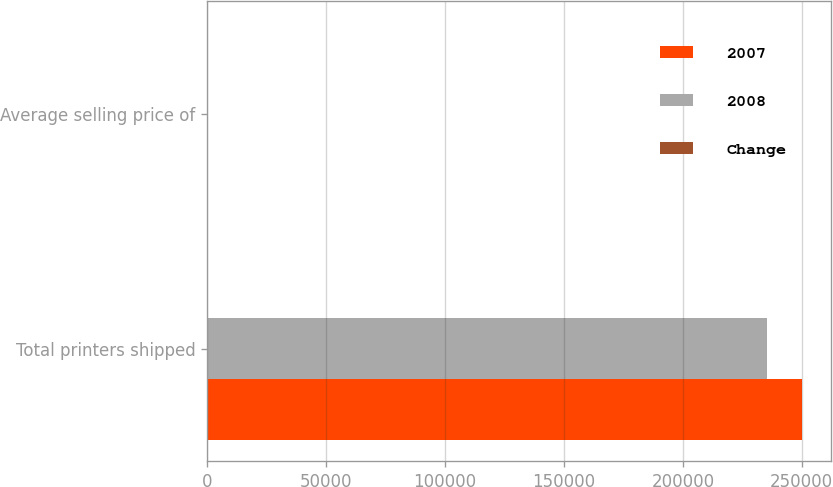Convert chart. <chart><loc_0><loc_0><loc_500><loc_500><stacked_bar_chart><ecel><fcel>Total printers shipped<fcel>Average selling price of<nl><fcel>2007<fcel>249902<fcel>538<nl><fcel>2008<fcel>235267<fcel>600<nl><fcel>Change<fcel>6.2<fcel>10.3<nl></chart> 